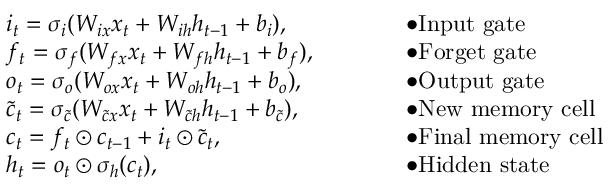<formula> <loc_0><loc_0><loc_500><loc_500>\begin{array} { r l r l } & { i _ { t } = \sigma _ { i } ( W _ { i x } x _ { t } + W _ { i h } h _ { t - 1 } + b _ { i } ) , } & & { \bullet I n p u t g a t e } \\ & { f _ { t } = \sigma _ { f } ( W _ { f x } x _ { t } + W _ { f h } h _ { t - 1 } + b _ { f } ) , \quad } & & { \bullet F o r g e t g a t e } \\ & { o _ { t } = \sigma _ { o } ( W _ { o x } x _ { t } + W _ { o h } h _ { t - 1 } + b _ { o } ) , } & & { \bullet O u t p u t g a t e } \\ & { \tilde { c } _ { t } = \sigma _ { \tilde { c } } ( W _ { \tilde { c } x } x _ { t } + W _ { \tilde { c } h } h _ { t - 1 } + b _ { \tilde { c } } ) , } & & { \bullet N e w m e m o r y c e l l } \\ & { c _ { t } = f _ { t } \odot c _ { t - 1 } + i _ { t } \odot \tilde { c } _ { t } , } & & { \bullet F i n a l m e m o r y c e l l } \\ & { h _ { t } = o _ { t } \odot \sigma _ { h } ( c _ { t } ) , } & & { \bullet H i d d e n s t a t e } \end{array}</formula> 